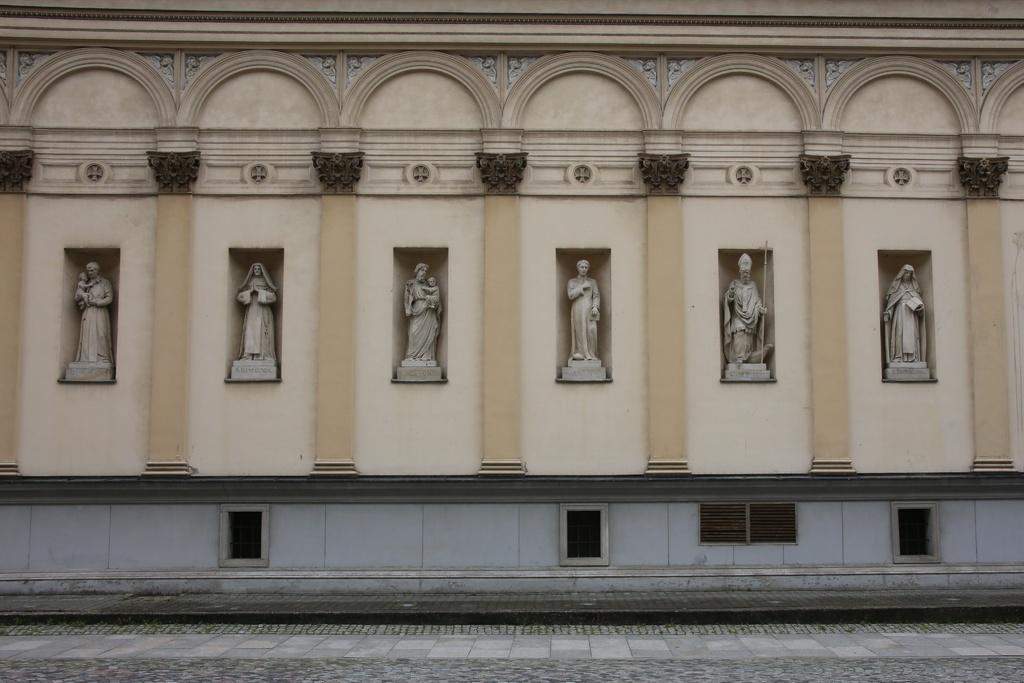In one or two sentences, can you explain what this image depicts? In this image there is one building and also there are some statues, at the bottom there is a walkway. 